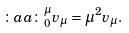Convert formula to latex. <formula><loc_0><loc_0><loc_500><loc_500>\colon a a \colon ^ { \mu } _ { 0 } v _ { \mu } = \mu ^ { 2 } v _ { \mu } .</formula> 